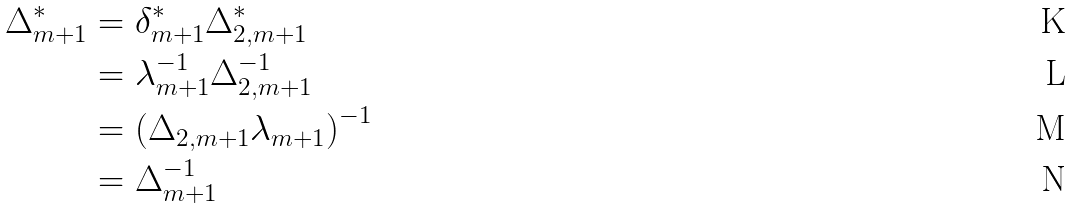Convert formula to latex. <formula><loc_0><loc_0><loc_500><loc_500>\Delta _ { m + 1 } ^ { * } & = \delta _ { m + 1 } ^ { * } \Delta _ { 2 , m + 1 } ^ { * } \\ & = \lambda _ { m + 1 } ^ { - 1 } \Delta _ { 2 , m + 1 } ^ { - 1 } \\ & = \left ( \Delta _ { 2 , m + 1 } \lambda _ { m + 1 } \right ) ^ { - 1 } \\ & = \Delta _ { m + 1 } ^ { - 1 }</formula> 